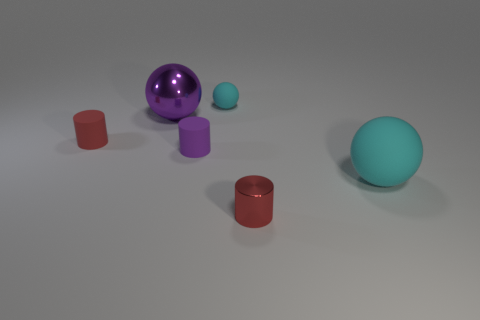Is the number of purple rubber objects that are to the right of the big purple metal ball less than the number of things on the right side of the small cyan rubber object?
Ensure brevity in your answer.  Yes. What number of other objects are the same material as the tiny cyan ball?
Offer a terse response. 3. Do the large purple ball and the purple cylinder have the same material?
Give a very brief answer. No. How many other objects are the same size as the red matte cylinder?
Offer a terse response. 3. There is a cyan rubber ball that is in front of the metal object that is behind the small purple cylinder; what size is it?
Provide a short and direct response. Large. There is a metallic ball on the left side of the cyan ball that is on the left side of the red cylinder that is right of the big purple thing; what is its color?
Offer a terse response. Purple. What is the size of the thing that is both on the right side of the purple metallic sphere and behind the red matte cylinder?
Keep it short and to the point. Small. How many balls are tiny red shiny things or purple things?
Offer a very short reply. 1. Are there any big spheres that are on the right side of the red cylinder in front of the cyan object right of the red metallic thing?
Offer a very short reply. Yes. The metal object that is the same shape as the large matte thing is what color?
Ensure brevity in your answer.  Purple. 